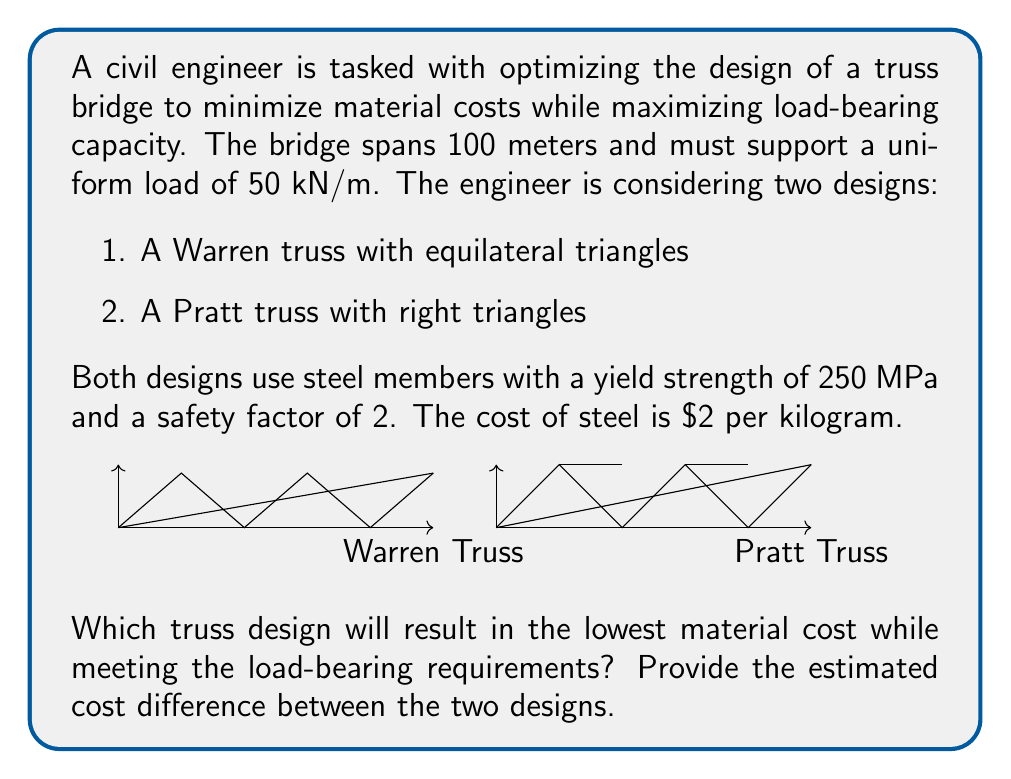Can you solve this math problem? Let's approach this step-by-step:

1) First, we need to calculate the optimal height for each truss design. The optimal height-to-span ratio for trusses is typically around 1/10 to 1/8 of the span length.

   Optimal height ≈ 100m × (1/9) ≈ 11.1m

2) For the Warren truss:
   - Number of triangles = 100m ÷ (11.1m × √3) ≈ 5.2, rounded up to 6
   - Actual panel length = 100m ÷ 6 ≈ 16.67m
   - Member length = √(16.67² + 11.1²) ≈ 20m

3) For the Pratt truss:
   - Number of panels = 100m ÷ 11.1m ≈ 9
   - Actual panel length = 100m ÷ 9 ≈ 11.1m
   - Diagonal member length = √(11.1² + 11.1²) ≈ 15.7m

4) Calculate the maximum force in the members:
   $$F_{max} = \frac{wL^2}{8h}$$
   where w = 50 kN/m, L = 100m, h = 11.1m
   
   $$F_{max} = \frac{50 × 100^2}{8 × 11.1} ≈ 5631.3 kN$$

5) Required cross-sectional area:
   $$A = \frac{F_{max} × SF}{σ_y}$$
   where SF = 2 (safety factor), σ_y = 250 MPa

   $$A = \frac{5631.3 × 10^3 × 2}{250 × 10^6} ≈ 0.045 m^2 = 45000 mm^2$$

6) Assuming we use hollow circular sections, we can estimate the mass per meter:
   Mass per meter ≈ 45000 mm² × 7850 kg/m³ × 10⁻⁶ m²/mm² ≈ 353.25 kg/m

7) Total length of members:
   - Warren truss: (12 × 20m) + (100m × 2) = 440m
   - Pratt truss: (18 × 11.1m) + (16 × 15.7m) + (100m × 2) = 551.2m

8) Total mass of steel:
   - Warren truss: 440m × 353.25 kg/m = 155,430 kg
   - Pratt truss: 551.2m × 353.25 kg/m = 194,711 kg

9) Total cost:
   - Warren truss: 155,430 kg × $2/kg = $310,860
   - Pratt truss: 194,711 kg × $2/kg = $389,422

The difference in cost is $389,422 - $310,860 = $78,562
Answer: Warren truss; $78,562 less than Pratt truss 